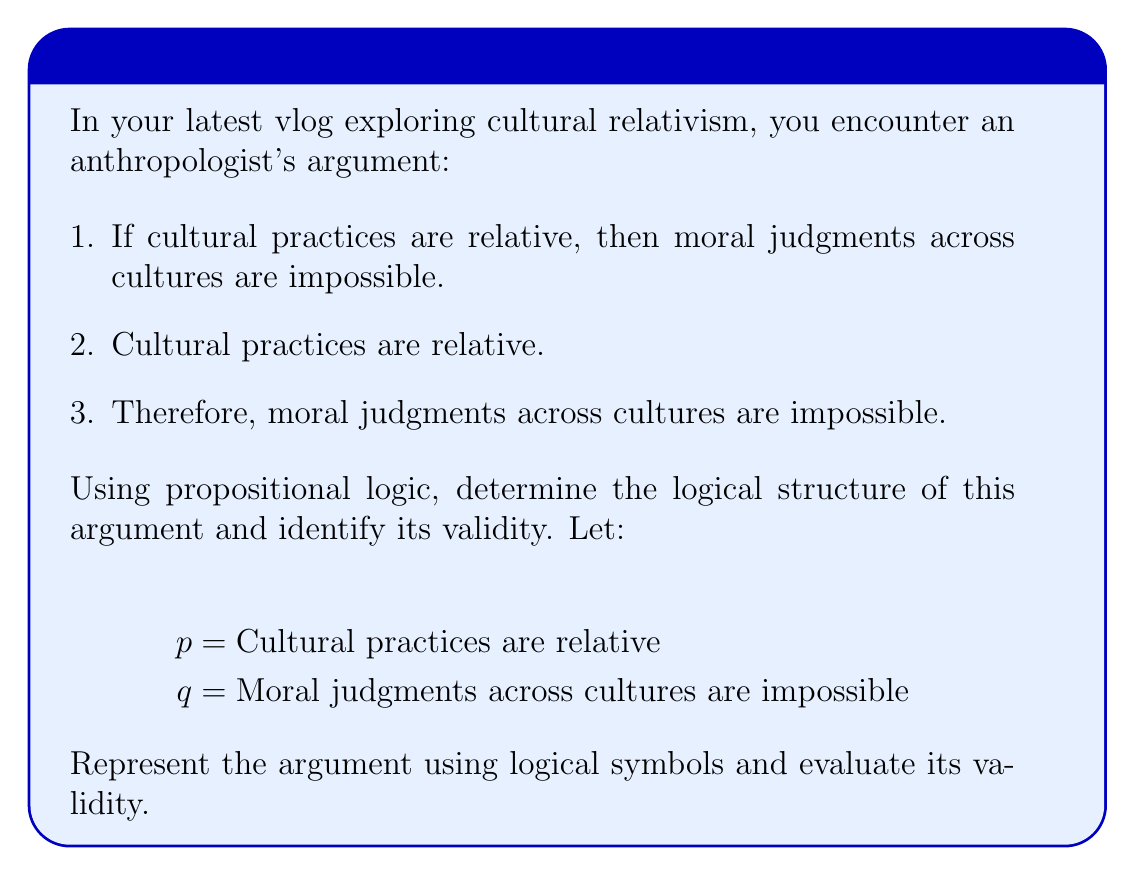Can you answer this question? Let's break this down step-by-step:

1) First, we need to translate the argument into symbolic form:

   Premise 1: $p \rightarrow q$
   Premise 2: $p$
   Conclusion: $q$

2) This logical structure is known as Modus Ponens, which has the form:
   
   $$
   \begin{align}
   p \rightarrow q \\
   p \\
   \therefore q
   \end{align}
   $$

3) To evaluate the validity of this argument, we need to understand that a valid argument is one where if all premises are true, the conclusion must be true.

4) In Modus Ponens:
   - If $p \rightarrow q$ is true (Premise 1)
   - And $p$ is true (Premise 2)
   - Then $q$ must be true (Conclusion)

5) This is because if $p$ implies $q$, and $p$ is indeed true, then $q$ must necessarily be true.

6) Therefore, this argument structure is valid. It's important to note that validity doesn't speak to the truth of the premises or conclusion, only that the conclusion follows logically from the premises.

7) In the context of anthropology, this means that if we accept both premises as true, we must accept the conclusion. However, an anthropologist might challenge the truth of either premise, particularly the first one, which makes a strong claim about the relationship between cultural relativism and moral judgments.
Answer: Valid Modus Ponens argument: $((p \rightarrow q) \land p) \rightarrow q$ 